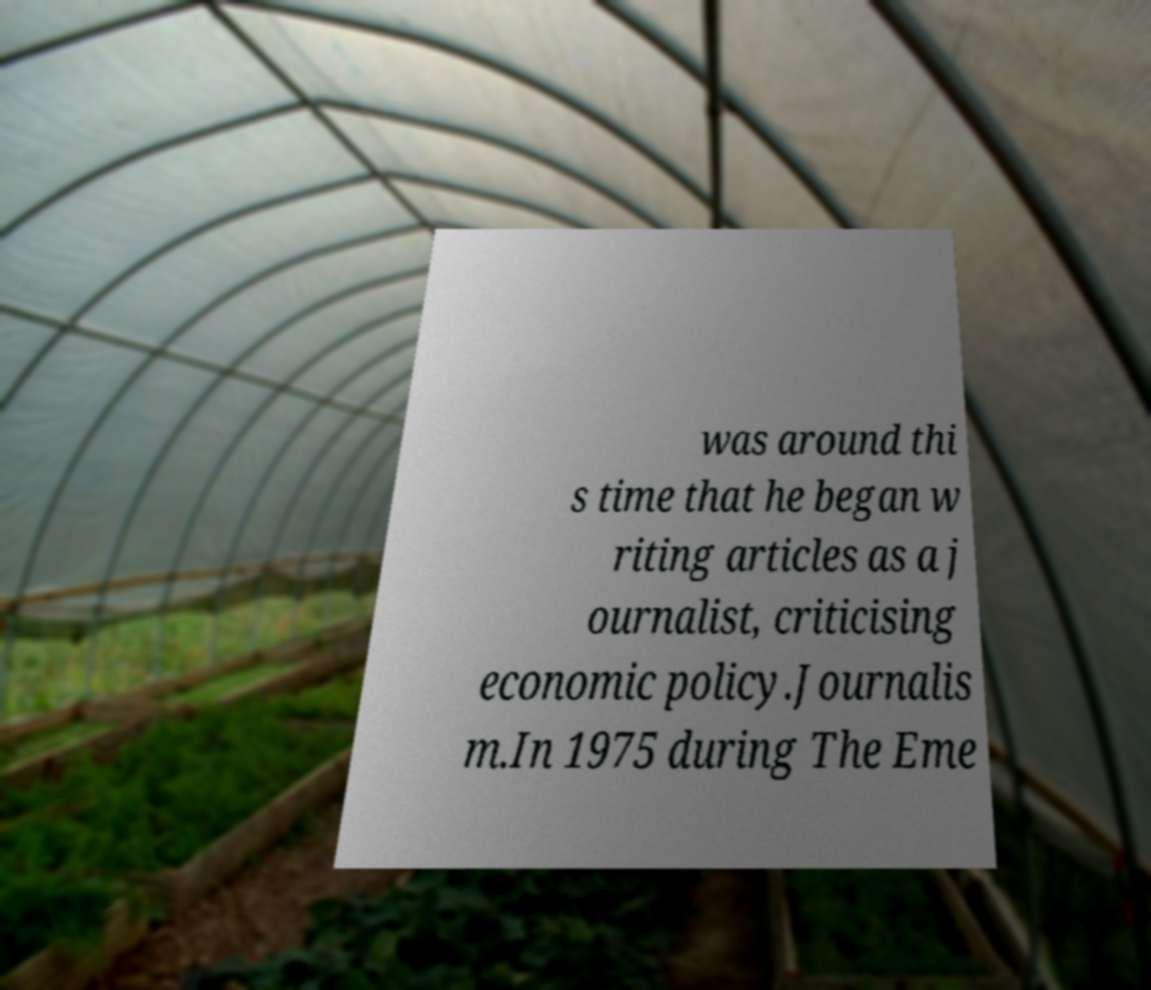What messages or text are displayed in this image? I need them in a readable, typed format. was around thi s time that he began w riting articles as a j ournalist, criticising economic policy.Journalis m.In 1975 during The Eme 